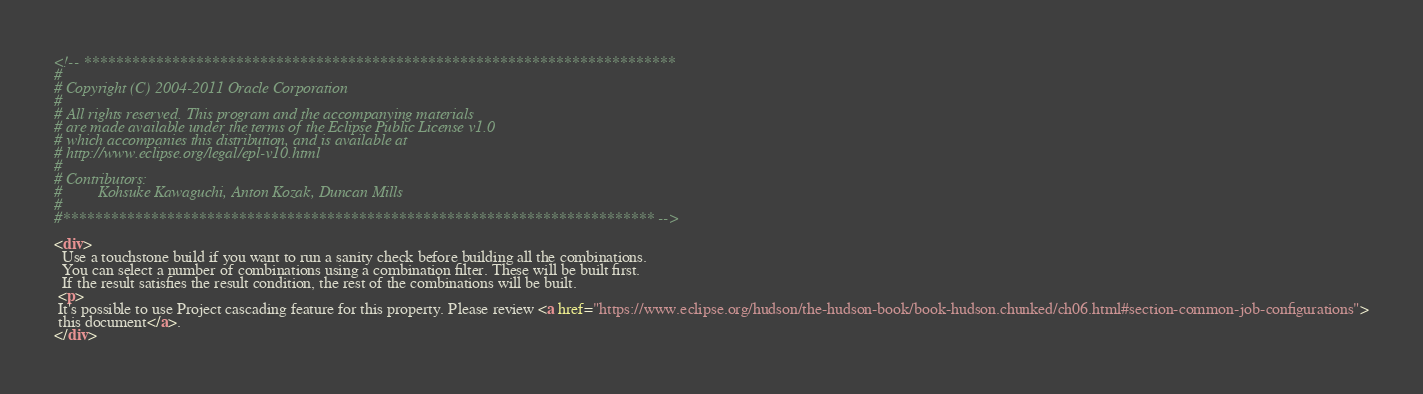<code> <loc_0><loc_0><loc_500><loc_500><_HTML_><!-- **************************************************************************
#
# Copyright (C) 2004-2011 Oracle Corporation
#
# All rights reserved. This program and the accompanying materials
# are made available under the terms of the Eclipse Public License v1.0
# which accompanies this distribution, and is available at
# http://www.eclipse.org/legal/epl-v10.html
#
# Contributors:
#         Kohsuke Kawaguchi, Anton Kozak, Duncan Mills
#
#************************************************************************** -->

<div>
  Use a touchstone build if you want to run a sanity check before building all the combinations.
  You can select a number of combinations using a combination filter. These will be built first.
  If the result satisfies the result condition, the rest of the combinations will be built.
 <p>
 It's possible to use Project cascading feature for this property. Please review <a href="https://www.eclipse.org/hudson/the-hudson-book/book-hudson.chunked/ch06.html#section-common-job-configurations">
 this document</a>.
</div></code> 